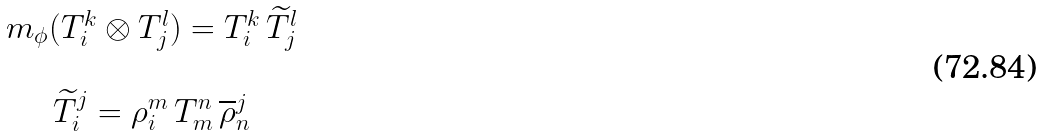<formula> <loc_0><loc_0><loc_500><loc_500>\begin{array} { c } m _ { \phi } ( T _ { i } ^ { k } \otimes T _ { j } ^ { l } ) = T _ { i } ^ { k } \, \widetilde { T } _ { j } ^ { l } \\ \\ \widetilde { T } _ { i } ^ { j } = \rho _ { i } ^ { m } \, T _ { m } ^ { n } \, \overline { \rho } _ { n } ^ { j } \end{array}</formula> 